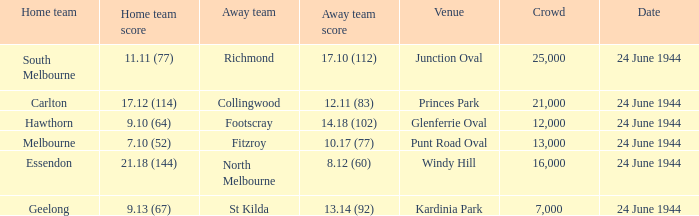When Essendon was the Home Team, what was the Away Team score? 8.12 (60). 